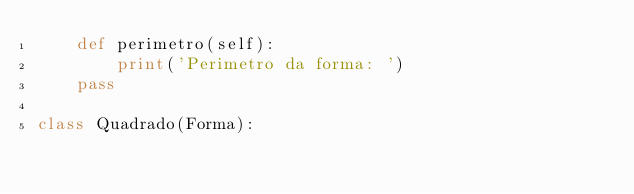<code> <loc_0><loc_0><loc_500><loc_500><_Python_>    def perimetro(self):
        print('Perimetro da forma: ')
    pass

class Quadrado(Forma):
</code> 